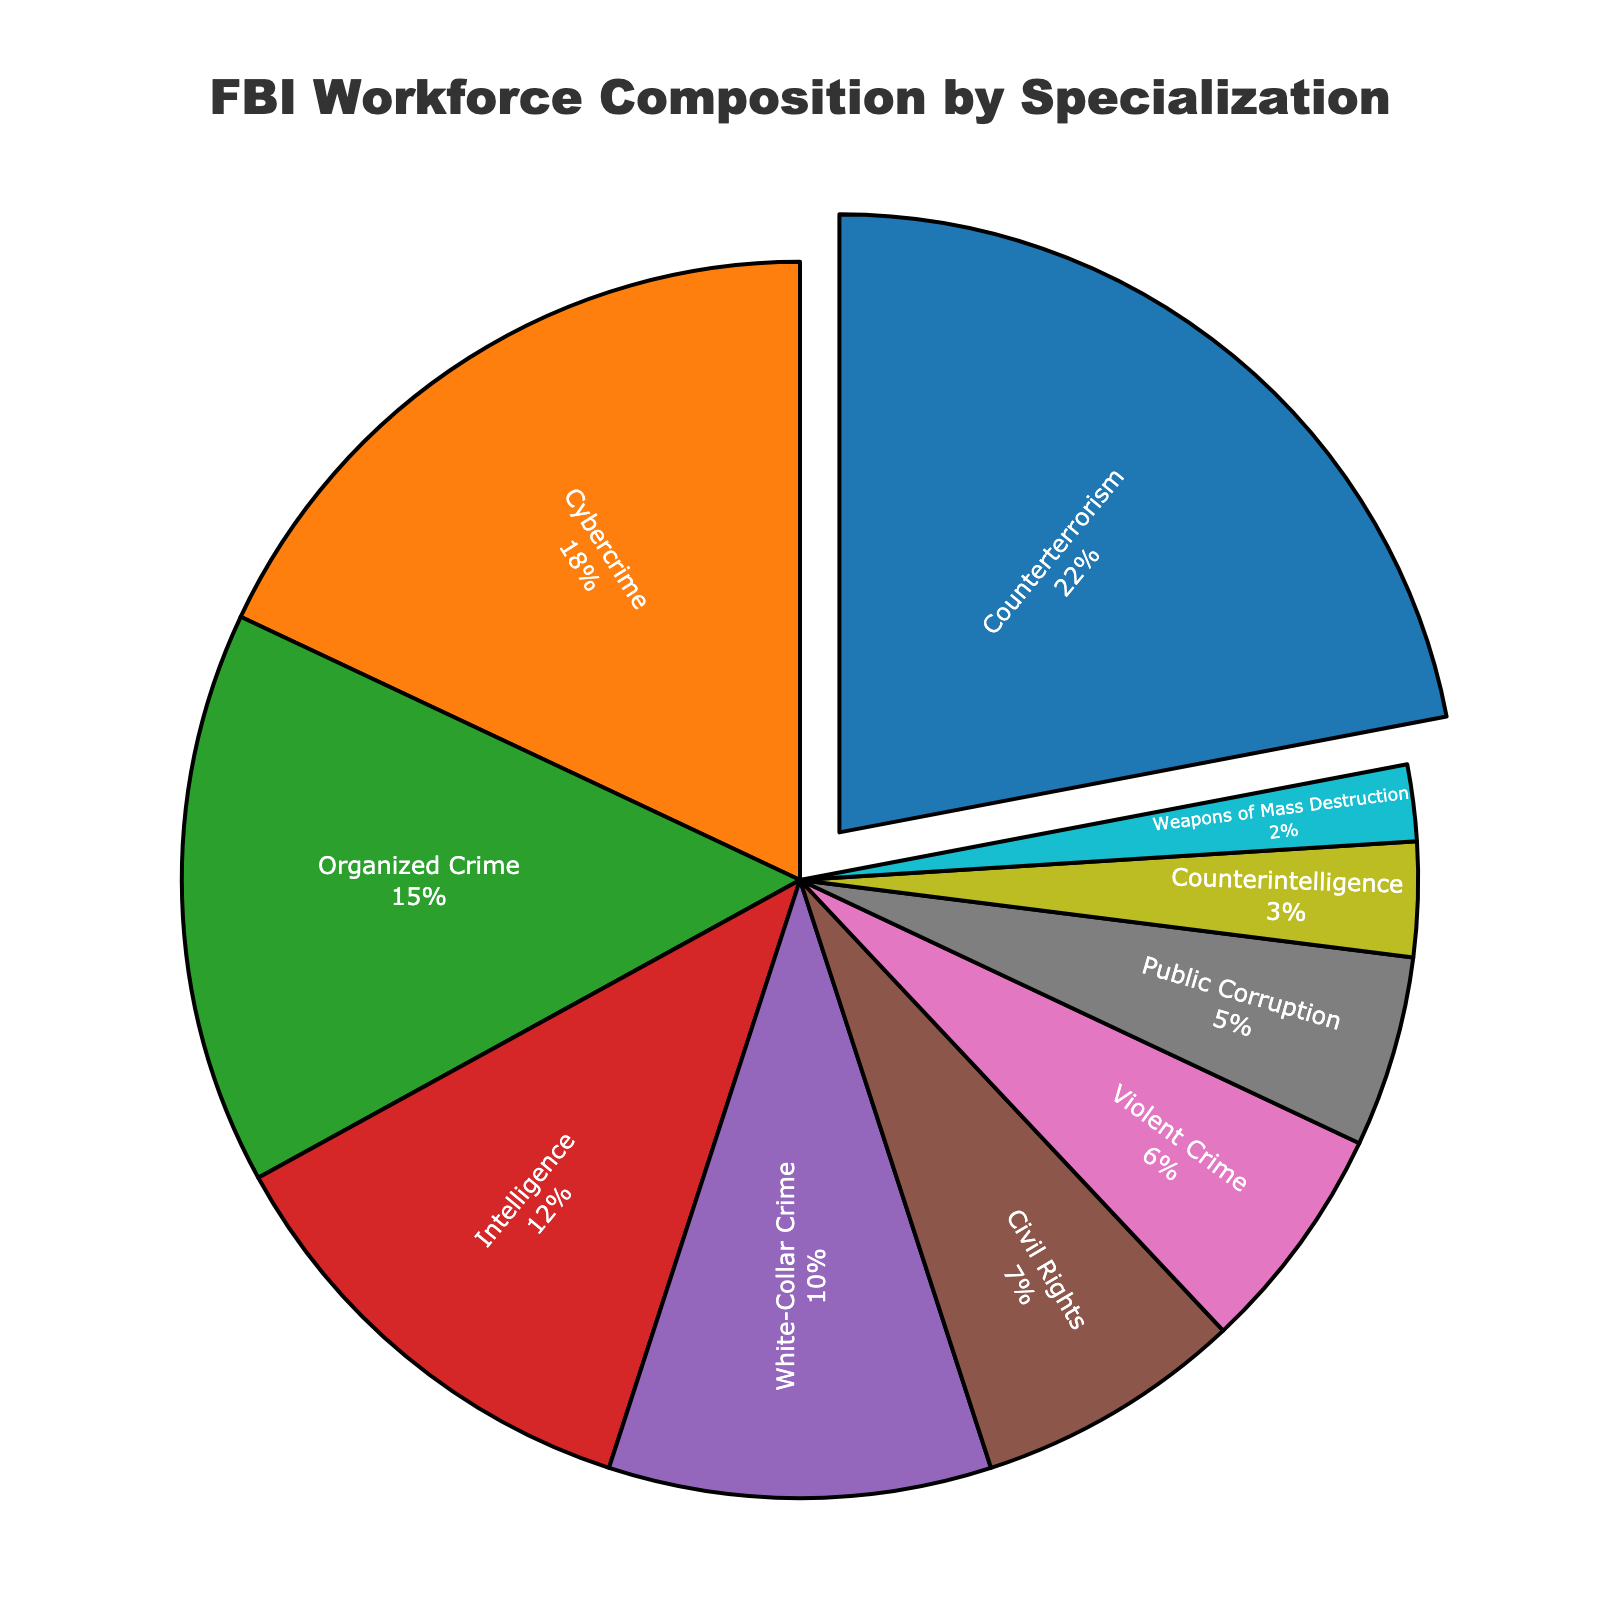which specialization has the highest percentage of the FBI workforce? The specialization with the highest percentage will be the one with the largest segment of the pie chart. From our data, the largest segment is labeled 'Counterterrorism' with 22%.
Answer: Counterterrorism What is the combined percentage of FBI workforce in cybercrime and white-collar crime? To find the combined percentage, add the percentages for Cybercrime (18%) and White-Collar Crime (10%). 18% + 10% = 28%
Answer: 28% Which specializations make up less than 10% of the FBI workforce? Look for the segments that have percentages labeled less than 10%. These are Civil Rights (7%), Violent Crime (6%), Public Corruption (5%), Counterintelligence (3%), and Weapons of Mass Destruction (2%).
Answer: Civil Rights, Violent Crime, Public Corruption, Counterintelligence, Weapons of Mass Destruction How much larger is the counterterrorism specialization compared to the weapons of mass destruction specialization? To find the difference, subtract the Weapons of Mass Destruction percentage (2%) from the Counterterrorism percentage (22%). 22% - 2% = 20%
Answer: 20% Between organized crime and civil rights, which specialization has a higher percentage and by how much? Compare the percentages: Organized Crime (15%) and Civil Rights (7%). Subtract the smaller percentage from the larger one: 15% - 7% = 8%
Answer: Organized Crime by 8% Is the percentage of FBI workforce in counterterrorism more than double the percentage in public corruption? Double the percentage of Public Corruption, which is 5%, giving 10%. Since Counterterrorism is 22%, which is more than 10%, the answer is yes.
Answer: Yes Which specialization has the smallest percentage of the FBI workforce? The smallest segment of the pie chart represents the specialization with the smallest percentage. This is the Weapons of Mass Destruction specialization with 2%.
Answer: Weapons of Mass Destruction If you combine the percentages of violent crime, civil rights, and public corruption, do they add up to more than 20%? Add their percentages: Violent Crime (6%), Civil Rights (7%), Public Corruption (5%). 6% + 7% + 5% = 18%, which is less than 20%.
Answer: No What is the difference between the percentage of workforce in intelligence and cybercrime specializations? Subtract the smaller percentage (Intelligence at 12%) from the larger one (Cybercrime at 18%). 18% - 12% = 6%
Answer: 6% What specialization is represented by the green segment on the pie chart? By color-coding, identify the green segment in the pie chart. Based on our given color sequence and data, the green segment represents Organized Crime.
Answer: Organized Crime 